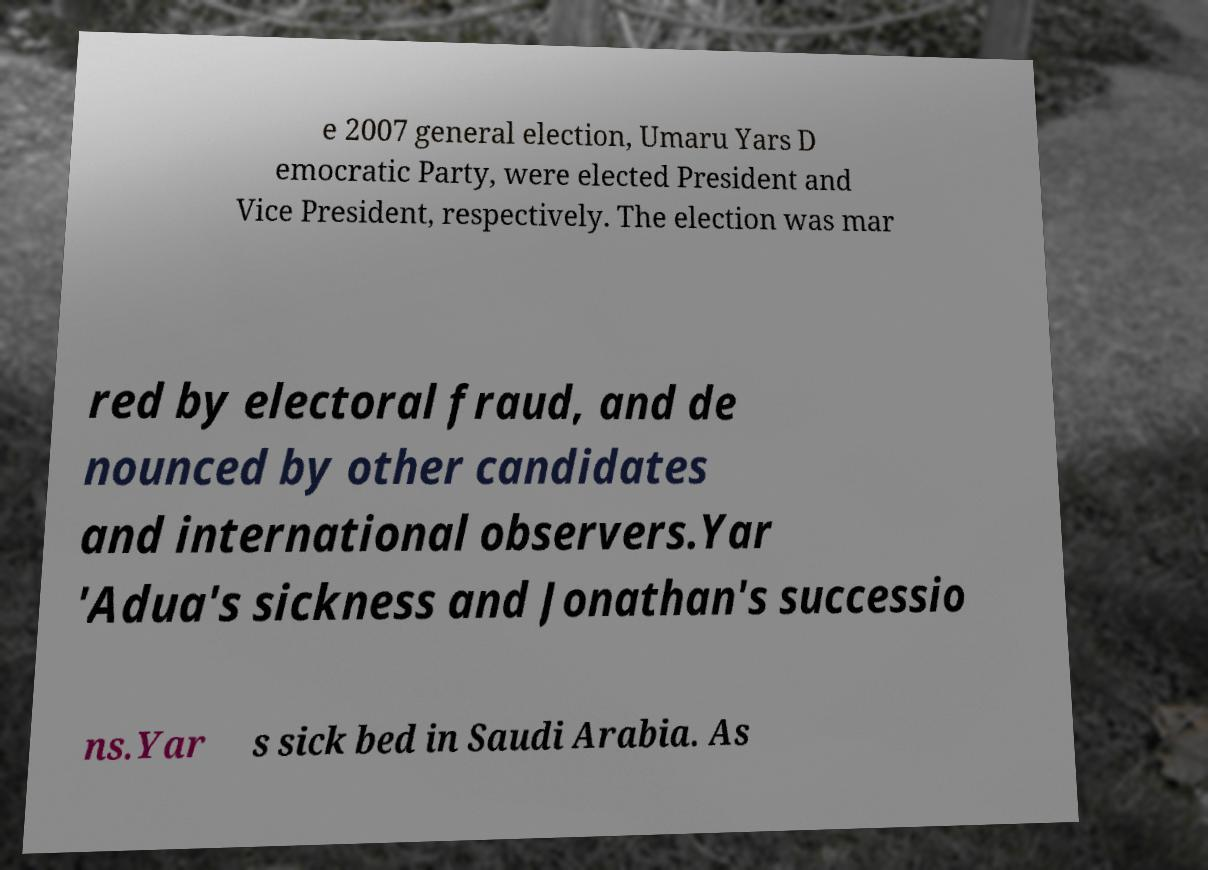Please identify and transcribe the text found in this image. e 2007 general election, Umaru Yars D emocratic Party, were elected President and Vice President, respectively. The election was mar red by electoral fraud, and de nounced by other candidates and international observers.Yar 'Adua's sickness and Jonathan's successio ns.Yar s sick bed in Saudi Arabia. As 